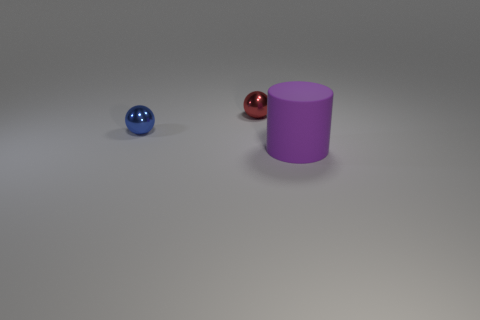What shape is the shiny thing that is the same size as the red shiny sphere?
Ensure brevity in your answer.  Sphere. How big is the red shiny object?
Provide a short and direct response. Small. There is a thing behind the blue sphere; does it have the same size as the cylinder right of the blue sphere?
Offer a terse response. No. There is a tiny sphere left of the sphere that is behind the tiny blue ball; what is its color?
Give a very brief answer. Blue. What material is the sphere that is the same size as the blue shiny thing?
Keep it short and to the point. Metal. How many metallic things are either big brown cubes or small balls?
Keep it short and to the point. 2. What is the color of the thing that is to the right of the blue shiny ball and in front of the small red metallic thing?
Your answer should be very brief. Purple. How many purple cylinders are in front of the purple cylinder?
Your answer should be compact. 0. What material is the red sphere?
Offer a terse response. Metal. There is a tiny object that is behind the object on the left side of the small metallic object on the right side of the tiny blue sphere; what is its color?
Offer a terse response. Red. 